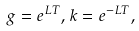<formula> <loc_0><loc_0><loc_500><loc_500>g = e ^ { L T } , k = e ^ { - L T } ,</formula> 